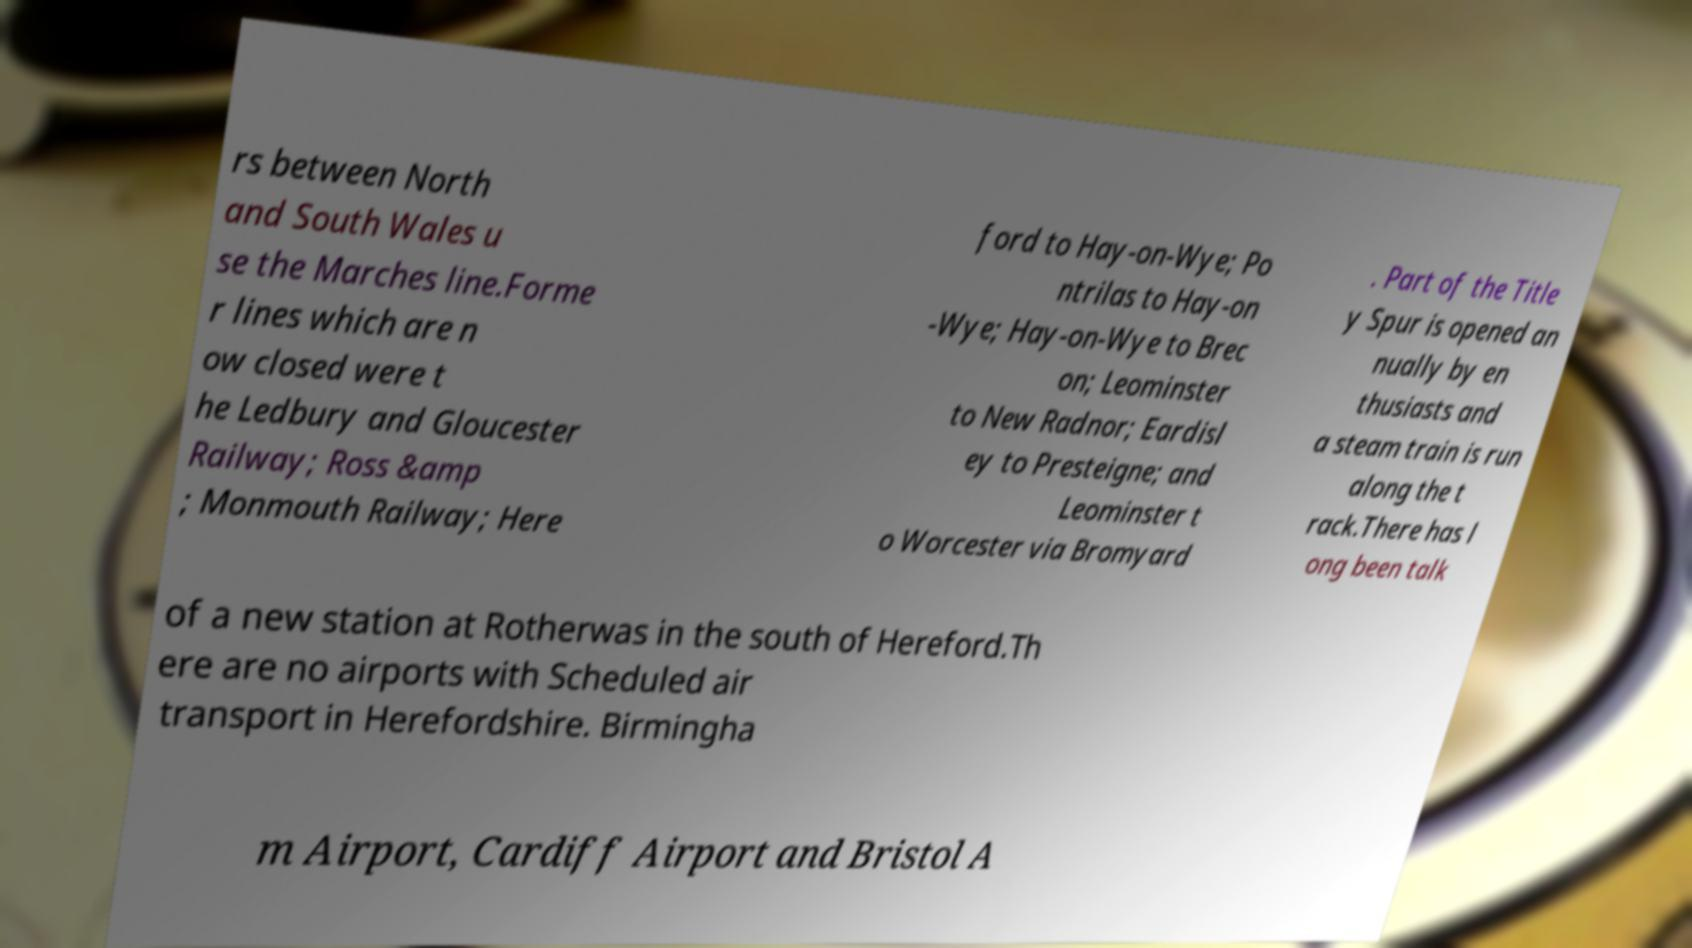Could you assist in decoding the text presented in this image and type it out clearly? rs between North and South Wales u se the Marches line.Forme r lines which are n ow closed were t he Ledbury and Gloucester Railway; Ross &amp ; Monmouth Railway; Here ford to Hay-on-Wye; Po ntrilas to Hay-on -Wye; Hay-on-Wye to Brec on; Leominster to New Radnor; Eardisl ey to Presteigne; and Leominster t o Worcester via Bromyard . Part of the Title y Spur is opened an nually by en thusiasts and a steam train is run along the t rack.There has l ong been talk of a new station at Rotherwas in the south of Hereford.Th ere are no airports with Scheduled air transport in Herefordshire. Birmingha m Airport, Cardiff Airport and Bristol A 